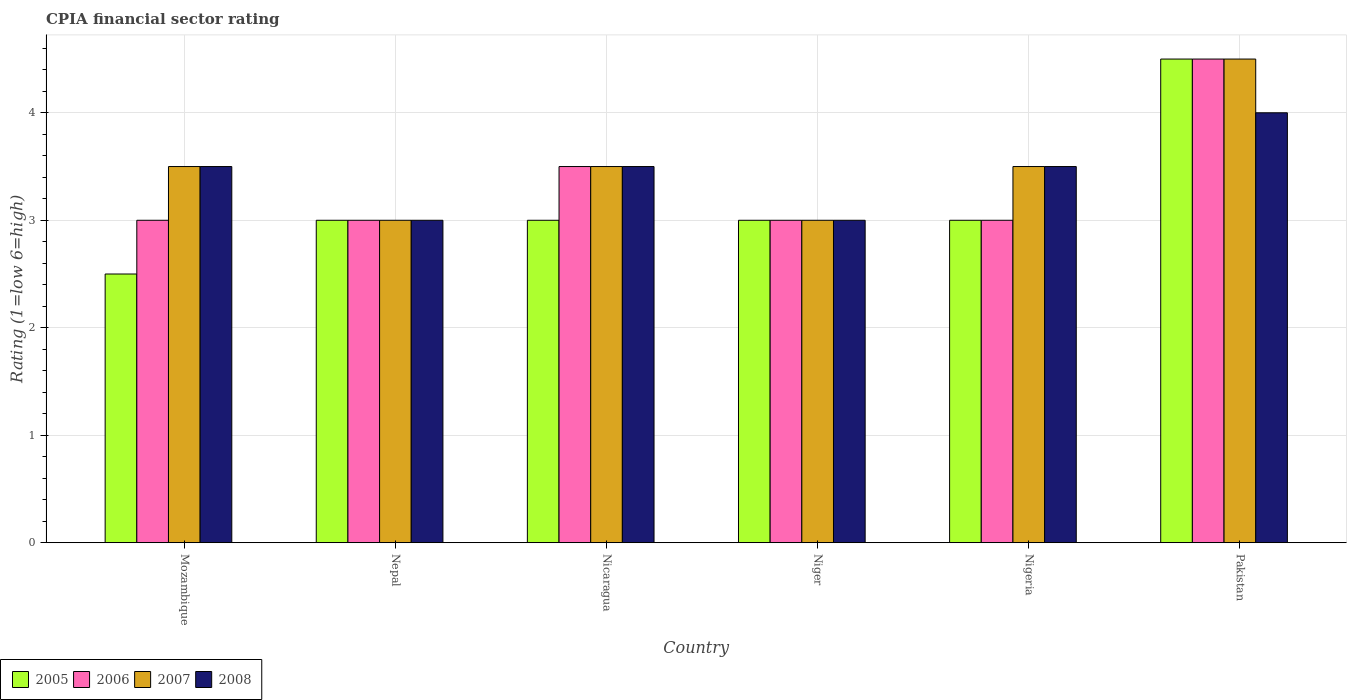How many different coloured bars are there?
Make the answer very short. 4. Are the number of bars on each tick of the X-axis equal?
Make the answer very short. Yes. How many bars are there on the 2nd tick from the left?
Offer a very short reply. 4. How many bars are there on the 2nd tick from the right?
Your answer should be very brief. 4. What is the label of the 2nd group of bars from the left?
Provide a short and direct response. Nepal. Across all countries, what is the minimum CPIA rating in 2006?
Offer a terse response. 3. In which country was the CPIA rating in 2008 maximum?
Make the answer very short. Pakistan. In which country was the CPIA rating in 2008 minimum?
Your response must be concise. Nepal. What is the average CPIA rating in 2005 per country?
Provide a succinct answer. 3.17. In how many countries, is the CPIA rating in 2006 greater than 0.2?
Give a very brief answer. 6. What is the ratio of the CPIA rating in 2006 in Mozambique to that in Niger?
Provide a short and direct response. 1. Is the CPIA rating in 2008 in Nepal less than that in Pakistan?
Your answer should be very brief. Yes. Is the difference between the CPIA rating in 2008 in Nicaragua and Nigeria greater than the difference between the CPIA rating in 2006 in Nicaragua and Nigeria?
Your answer should be compact. No. What is the difference between the highest and the second highest CPIA rating in 2006?
Your answer should be compact. -0.5. Is it the case that in every country, the sum of the CPIA rating in 2007 and CPIA rating in 2006 is greater than the sum of CPIA rating in 2005 and CPIA rating in 2008?
Provide a short and direct response. No. What does the 4th bar from the left in Nigeria represents?
Provide a short and direct response. 2008. How many bars are there?
Give a very brief answer. 24. Are all the bars in the graph horizontal?
Your answer should be very brief. No. How many countries are there in the graph?
Your response must be concise. 6. What is the difference between two consecutive major ticks on the Y-axis?
Make the answer very short. 1. Does the graph contain grids?
Offer a terse response. Yes. Where does the legend appear in the graph?
Offer a very short reply. Bottom left. How many legend labels are there?
Ensure brevity in your answer.  4. How are the legend labels stacked?
Ensure brevity in your answer.  Horizontal. What is the title of the graph?
Ensure brevity in your answer.  CPIA financial sector rating. Does "2011" appear as one of the legend labels in the graph?
Your response must be concise. No. What is the label or title of the Y-axis?
Provide a short and direct response. Rating (1=low 6=high). What is the Rating (1=low 6=high) of 2005 in Mozambique?
Offer a terse response. 2.5. What is the Rating (1=low 6=high) in 2006 in Mozambique?
Ensure brevity in your answer.  3. What is the Rating (1=low 6=high) in 2007 in Mozambique?
Keep it short and to the point. 3.5. What is the Rating (1=low 6=high) of 2005 in Nepal?
Offer a very short reply. 3. What is the Rating (1=low 6=high) in 2007 in Nepal?
Offer a terse response. 3. What is the Rating (1=low 6=high) of 2008 in Nepal?
Make the answer very short. 3. What is the Rating (1=low 6=high) in 2005 in Nicaragua?
Offer a terse response. 3. What is the Rating (1=low 6=high) in 2006 in Nicaragua?
Ensure brevity in your answer.  3.5. What is the Rating (1=low 6=high) in 2007 in Nicaragua?
Ensure brevity in your answer.  3.5. What is the Rating (1=low 6=high) of 2008 in Nicaragua?
Your response must be concise. 3.5. What is the Rating (1=low 6=high) of 2005 in Niger?
Ensure brevity in your answer.  3. What is the Rating (1=low 6=high) of 2007 in Niger?
Ensure brevity in your answer.  3. What is the Rating (1=low 6=high) in 2008 in Nigeria?
Ensure brevity in your answer.  3.5. What is the Rating (1=low 6=high) in 2007 in Pakistan?
Offer a very short reply. 4.5. What is the Rating (1=low 6=high) of 2008 in Pakistan?
Make the answer very short. 4. Across all countries, what is the maximum Rating (1=low 6=high) of 2007?
Your answer should be compact. 4.5. Across all countries, what is the minimum Rating (1=low 6=high) in 2005?
Give a very brief answer. 2.5. Across all countries, what is the minimum Rating (1=low 6=high) of 2008?
Your response must be concise. 3. What is the total Rating (1=low 6=high) of 2005 in the graph?
Ensure brevity in your answer.  19. What is the difference between the Rating (1=low 6=high) of 2006 in Mozambique and that in Nepal?
Make the answer very short. 0. What is the difference between the Rating (1=low 6=high) of 2008 in Mozambique and that in Nepal?
Give a very brief answer. 0.5. What is the difference between the Rating (1=low 6=high) in 2005 in Mozambique and that in Nicaragua?
Ensure brevity in your answer.  -0.5. What is the difference between the Rating (1=low 6=high) in 2006 in Mozambique and that in Nicaragua?
Your answer should be very brief. -0.5. What is the difference between the Rating (1=low 6=high) in 2007 in Mozambique and that in Nicaragua?
Your answer should be very brief. 0. What is the difference between the Rating (1=low 6=high) in 2006 in Mozambique and that in Niger?
Your answer should be compact. 0. What is the difference between the Rating (1=low 6=high) in 2007 in Mozambique and that in Niger?
Provide a short and direct response. 0.5. What is the difference between the Rating (1=low 6=high) in 2008 in Mozambique and that in Niger?
Your response must be concise. 0.5. What is the difference between the Rating (1=low 6=high) of 2005 in Mozambique and that in Nigeria?
Ensure brevity in your answer.  -0.5. What is the difference between the Rating (1=low 6=high) of 2006 in Mozambique and that in Nigeria?
Ensure brevity in your answer.  0. What is the difference between the Rating (1=low 6=high) in 2007 in Mozambique and that in Nigeria?
Your answer should be compact. 0. What is the difference between the Rating (1=low 6=high) in 2008 in Mozambique and that in Nigeria?
Provide a short and direct response. 0. What is the difference between the Rating (1=low 6=high) of 2005 in Nepal and that in Nicaragua?
Keep it short and to the point. 0. What is the difference between the Rating (1=low 6=high) in 2006 in Nepal and that in Nicaragua?
Give a very brief answer. -0.5. What is the difference between the Rating (1=low 6=high) of 2008 in Nepal and that in Niger?
Your response must be concise. 0. What is the difference between the Rating (1=low 6=high) in 2008 in Nepal and that in Nigeria?
Provide a short and direct response. -0.5. What is the difference between the Rating (1=low 6=high) in 2005 in Nepal and that in Pakistan?
Offer a very short reply. -1.5. What is the difference between the Rating (1=low 6=high) in 2007 in Nepal and that in Pakistan?
Keep it short and to the point. -1.5. What is the difference between the Rating (1=low 6=high) of 2008 in Nepal and that in Pakistan?
Your answer should be compact. -1. What is the difference between the Rating (1=low 6=high) of 2006 in Nicaragua and that in Niger?
Provide a short and direct response. 0.5. What is the difference between the Rating (1=low 6=high) in 2007 in Nicaragua and that in Niger?
Offer a terse response. 0.5. What is the difference between the Rating (1=low 6=high) of 2008 in Nicaragua and that in Niger?
Offer a terse response. 0.5. What is the difference between the Rating (1=low 6=high) in 2005 in Nicaragua and that in Nigeria?
Provide a succinct answer. 0. What is the difference between the Rating (1=low 6=high) in 2005 in Nicaragua and that in Pakistan?
Make the answer very short. -1.5. What is the difference between the Rating (1=low 6=high) of 2006 in Nicaragua and that in Pakistan?
Ensure brevity in your answer.  -1. What is the difference between the Rating (1=low 6=high) of 2007 in Nicaragua and that in Pakistan?
Make the answer very short. -1. What is the difference between the Rating (1=low 6=high) in 2005 in Niger and that in Nigeria?
Your response must be concise. 0. What is the difference between the Rating (1=low 6=high) in 2006 in Niger and that in Nigeria?
Give a very brief answer. 0. What is the difference between the Rating (1=low 6=high) in 2006 in Niger and that in Pakistan?
Offer a very short reply. -1.5. What is the difference between the Rating (1=low 6=high) of 2007 in Niger and that in Pakistan?
Offer a very short reply. -1.5. What is the difference between the Rating (1=low 6=high) of 2008 in Niger and that in Pakistan?
Your answer should be very brief. -1. What is the difference between the Rating (1=low 6=high) of 2007 in Nigeria and that in Pakistan?
Make the answer very short. -1. What is the difference between the Rating (1=low 6=high) of 2008 in Nigeria and that in Pakistan?
Give a very brief answer. -0.5. What is the difference between the Rating (1=low 6=high) in 2005 in Mozambique and the Rating (1=low 6=high) in 2006 in Nepal?
Provide a succinct answer. -0.5. What is the difference between the Rating (1=low 6=high) of 2005 in Mozambique and the Rating (1=low 6=high) of 2008 in Nepal?
Your answer should be very brief. -0.5. What is the difference between the Rating (1=low 6=high) in 2006 in Mozambique and the Rating (1=low 6=high) in 2007 in Nepal?
Offer a terse response. 0. What is the difference between the Rating (1=low 6=high) of 2006 in Mozambique and the Rating (1=low 6=high) of 2008 in Nepal?
Offer a very short reply. 0. What is the difference between the Rating (1=low 6=high) in 2005 in Mozambique and the Rating (1=low 6=high) in 2006 in Nicaragua?
Give a very brief answer. -1. What is the difference between the Rating (1=low 6=high) of 2005 in Mozambique and the Rating (1=low 6=high) of 2008 in Nicaragua?
Your answer should be compact. -1. What is the difference between the Rating (1=low 6=high) in 2006 in Mozambique and the Rating (1=low 6=high) in 2008 in Nicaragua?
Provide a short and direct response. -0.5. What is the difference between the Rating (1=low 6=high) of 2007 in Mozambique and the Rating (1=low 6=high) of 2008 in Nicaragua?
Your answer should be compact. 0. What is the difference between the Rating (1=low 6=high) of 2005 in Mozambique and the Rating (1=low 6=high) of 2006 in Niger?
Offer a very short reply. -0.5. What is the difference between the Rating (1=low 6=high) in 2005 in Mozambique and the Rating (1=low 6=high) in 2007 in Niger?
Keep it short and to the point. -0.5. What is the difference between the Rating (1=low 6=high) of 2005 in Mozambique and the Rating (1=low 6=high) of 2008 in Niger?
Your answer should be compact. -0.5. What is the difference between the Rating (1=low 6=high) of 2006 in Mozambique and the Rating (1=low 6=high) of 2007 in Niger?
Provide a succinct answer. 0. What is the difference between the Rating (1=low 6=high) in 2006 in Mozambique and the Rating (1=low 6=high) in 2008 in Niger?
Your answer should be very brief. 0. What is the difference between the Rating (1=low 6=high) in 2005 in Mozambique and the Rating (1=low 6=high) in 2007 in Nigeria?
Give a very brief answer. -1. What is the difference between the Rating (1=low 6=high) in 2005 in Mozambique and the Rating (1=low 6=high) in 2008 in Nigeria?
Give a very brief answer. -1. What is the difference between the Rating (1=low 6=high) in 2006 in Mozambique and the Rating (1=low 6=high) in 2007 in Nigeria?
Your answer should be compact. -0.5. What is the difference between the Rating (1=low 6=high) in 2006 in Mozambique and the Rating (1=low 6=high) in 2008 in Nigeria?
Give a very brief answer. -0.5. What is the difference between the Rating (1=low 6=high) of 2005 in Mozambique and the Rating (1=low 6=high) of 2006 in Pakistan?
Your response must be concise. -2. What is the difference between the Rating (1=low 6=high) in 2005 in Mozambique and the Rating (1=low 6=high) in 2007 in Pakistan?
Keep it short and to the point. -2. What is the difference between the Rating (1=low 6=high) of 2006 in Mozambique and the Rating (1=low 6=high) of 2008 in Pakistan?
Offer a very short reply. -1. What is the difference between the Rating (1=low 6=high) in 2005 in Nepal and the Rating (1=low 6=high) in 2007 in Nicaragua?
Ensure brevity in your answer.  -0.5. What is the difference between the Rating (1=low 6=high) of 2006 in Nepal and the Rating (1=low 6=high) of 2007 in Nicaragua?
Give a very brief answer. -0.5. What is the difference between the Rating (1=low 6=high) in 2006 in Nepal and the Rating (1=low 6=high) in 2008 in Nicaragua?
Your response must be concise. -0.5. What is the difference between the Rating (1=low 6=high) in 2007 in Nepal and the Rating (1=low 6=high) in 2008 in Nicaragua?
Your response must be concise. -0.5. What is the difference between the Rating (1=low 6=high) in 2005 in Nepal and the Rating (1=low 6=high) in 2006 in Niger?
Provide a short and direct response. 0. What is the difference between the Rating (1=low 6=high) of 2005 in Nepal and the Rating (1=low 6=high) of 2007 in Niger?
Your answer should be very brief. 0. What is the difference between the Rating (1=low 6=high) in 2005 in Nepal and the Rating (1=low 6=high) in 2008 in Niger?
Ensure brevity in your answer.  0. What is the difference between the Rating (1=low 6=high) in 2006 in Nepal and the Rating (1=low 6=high) in 2007 in Niger?
Provide a succinct answer. 0. What is the difference between the Rating (1=low 6=high) in 2006 in Nepal and the Rating (1=low 6=high) in 2008 in Niger?
Provide a short and direct response. 0. What is the difference between the Rating (1=low 6=high) of 2005 in Nepal and the Rating (1=low 6=high) of 2007 in Nigeria?
Offer a terse response. -0.5. What is the difference between the Rating (1=low 6=high) in 2007 in Nepal and the Rating (1=low 6=high) in 2008 in Nigeria?
Make the answer very short. -0.5. What is the difference between the Rating (1=low 6=high) of 2005 in Nepal and the Rating (1=low 6=high) of 2006 in Pakistan?
Keep it short and to the point. -1.5. What is the difference between the Rating (1=low 6=high) of 2007 in Nepal and the Rating (1=low 6=high) of 2008 in Pakistan?
Provide a short and direct response. -1. What is the difference between the Rating (1=low 6=high) of 2005 in Nicaragua and the Rating (1=low 6=high) of 2006 in Niger?
Ensure brevity in your answer.  0. What is the difference between the Rating (1=low 6=high) of 2005 in Nicaragua and the Rating (1=low 6=high) of 2008 in Niger?
Your response must be concise. 0. What is the difference between the Rating (1=low 6=high) in 2007 in Nicaragua and the Rating (1=low 6=high) in 2008 in Niger?
Provide a short and direct response. 0.5. What is the difference between the Rating (1=low 6=high) in 2005 in Nicaragua and the Rating (1=low 6=high) in 2006 in Nigeria?
Your answer should be very brief. 0. What is the difference between the Rating (1=low 6=high) of 2005 in Nicaragua and the Rating (1=low 6=high) of 2007 in Nigeria?
Offer a very short reply. -0.5. What is the difference between the Rating (1=low 6=high) of 2005 in Nicaragua and the Rating (1=low 6=high) of 2008 in Nigeria?
Make the answer very short. -0.5. What is the difference between the Rating (1=low 6=high) in 2005 in Nicaragua and the Rating (1=low 6=high) in 2006 in Pakistan?
Ensure brevity in your answer.  -1.5. What is the difference between the Rating (1=low 6=high) in 2006 in Nicaragua and the Rating (1=low 6=high) in 2007 in Pakistan?
Give a very brief answer. -1. What is the difference between the Rating (1=low 6=high) in 2007 in Nicaragua and the Rating (1=low 6=high) in 2008 in Pakistan?
Your answer should be compact. -0.5. What is the difference between the Rating (1=low 6=high) of 2005 in Niger and the Rating (1=low 6=high) of 2006 in Nigeria?
Your answer should be compact. 0. What is the difference between the Rating (1=low 6=high) in 2005 in Niger and the Rating (1=low 6=high) in 2007 in Nigeria?
Your answer should be compact. -0.5. What is the difference between the Rating (1=low 6=high) in 2005 in Niger and the Rating (1=low 6=high) in 2008 in Nigeria?
Provide a succinct answer. -0.5. What is the difference between the Rating (1=low 6=high) in 2006 in Niger and the Rating (1=low 6=high) in 2008 in Nigeria?
Your response must be concise. -0.5. What is the difference between the Rating (1=low 6=high) of 2005 in Niger and the Rating (1=low 6=high) of 2006 in Pakistan?
Your answer should be compact. -1.5. What is the difference between the Rating (1=low 6=high) in 2005 in Niger and the Rating (1=low 6=high) in 2007 in Pakistan?
Your answer should be compact. -1.5. What is the difference between the Rating (1=low 6=high) of 2005 in Niger and the Rating (1=low 6=high) of 2008 in Pakistan?
Make the answer very short. -1. What is the difference between the Rating (1=low 6=high) in 2006 in Niger and the Rating (1=low 6=high) in 2007 in Pakistan?
Your response must be concise. -1.5. What is the difference between the Rating (1=low 6=high) of 2006 in Niger and the Rating (1=low 6=high) of 2008 in Pakistan?
Provide a succinct answer. -1. What is the difference between the Rating (1=low 6=high) of 2007 in Niger and the Rating (1=low 6=high) of 2008 in Pakistan?
Ensure brevity in your answer.  -1. What is the difference between the Rating (1=low 6=high) in 2005 in Nigeria and the Rating (1=low 6=high) in 2006 in Pakistan?
Give a very brief answer. -1.5. What is the difference between the Rating (1=low 6=high) of 2006 in Nigeria and the Rating (1=low 6=high) of 2007 in Pakistan?
Offer a terse response. -1.5. What is the difference between the Rating (1=low 6=high) of 2006 in Nigeria and the Rating (1=low 6=high) of 2008 in Pakistan?
Make the answer very short. -1. What is the difference between the Rating (1=low 6=high) of 2007 in Nigeria and the Rating (1=low 6=high) of 2008 in Pakistan?
Ensure brevity in your answer.  -0.5. What is the average Rating (1=low 6=high) in 2005 per country?
Ensure brevity in your answer.  3.17. What is the average Rating (1=low 6=high) of 2006 per country?
Provide a short and direct response. 3.33. What is the average Rating (1=low 6=high) of 2008 per country?
Keep it short and to the point. 3.42. What is the difference between the Rating (1=low 6=high) of 2005 and Rating (1=low 6=high) of 2007 in Mozambique?
Make the answer very short. -1. What is the difference between the Rating (1=low 6=high) in 2006 and Rating (1=low 6=high) in 2007 in Mozambique?
Your response must be concise. -0.5. What is the difference between the Rating (1=low 6=high) of 2006 and Rating (1=low 6=high) of 2008 in Mozambique?
Your answer should be compact. -0.5. What is the difference between the Rating (1=low 6=high) of 2007 and Rating (1=low 6=high) of 2008 in Mozambique?
Offer a terse response. 0. What is the difference between the Rating (1=low 6=high) in 2005 and Rating (1=low 6=high) in 2006 in Nepal?
Ensure brevity in your answer.  0. What is the difference between the Rating (1=low 6=high) of 2005 and Rating (1=low 6=high) of 2008 in Nepal?
Your answer should be very brief. 0. What is the difference between the Rating (1=low 6=high) of 2006 and Rating (1=low 6=high) of 2008 in Nepal?
Offer a very short reply. 0. What is the difference between the Rating (1=low 6=high) in 2005 and Rating (1=low 6=high) in 2006 in Nicaragua?
Your response must be concise. -0.5. What is the difference between the Rating (1=low 6=high) in 2005 and Rating (1=low 6=high) in 2007 in Nicaragua?
Your response must be concise. -0.5. What is the difference between the Rating (1=low 6=high) in 2007 and Rating (1=low 6=high) in 2008 in Nicaragua?
Make the answer very short. 0. What is the difference between the Rating (1=low 6=high) in 2005 and Rating (1=low 6=high) in 2006 in Niger?
Keep it short and to the point. 0. What is the difference between the Rating (1=low 6=high) in 2006 and Rating (1=low 6=high) in 2007 in Niger?
Offer a very short reply. 0. What is the difference between the Rating (1=low 6=high) in 2005 and Rating (1=low 6=high) in 2006 in Nigeria?
Keep it short and to the point. 0. What is the difference between the Rating (1=low 6=high) of 2005 and Rating (1=low 6=high) of 2007 in Nigeria?
Your answer should be compact. -0.5. What is the difference between the Rating (1=low 6=high) in 2005 and Rating (1=low 6=high) in 2006 in Pakistan?
Ensure brevity in your answer.  0. What is the difference between the Rating (1=low 6=high) in 2005 and Rating (1=low 6=high) in 2008 in Pakistan?
Keep it short and to the point. 0.5. What is the difference between the Rating (1=low 6=high) in 2006 and Rating (1=low 6=high) in 2007 in Pakistan?
Ensure brevity in your answer.  0. What is the difference between the Rating (1=low 6=high) in 2006 and Rating (1=low 6=high) in 2008 in Pakistan?
Your response must be concise. 0.5. What is the difference between the Rating (1=low 6=high) of 2007 and Rating (1=low 6=high) of 2008 in Pakistan?
Offer a very short reply. 0.5. What is the ratio of the Rating (1=low 6=high) in 2005 in Mozambique to that in Nepal?
Ensure brevity in your answer.  0.83. What is the ratio of the Rating (1=low 6=high) of 2007 in Mozambique to that in Nepal?
Ensure brevity in your answer.  1.17. What is the ratio of the Rating (1=low 6=high) of 2008 in Mozambique to that in Nepal?
Keep it short and to the point. 1.17. What is the ratio of the Rating (1=low 6=high) of 2005 in Mozambique to that in Nicaragua?
Keep it short and to the point. 0.83. What is the ratio of the Rating (1=low 6=high) of 2006 in Mozambique to that in Nicaragua?
Ensure brevity in your answer.  0.86. What is the ratio of the Rating (1=low 6=high) of 2008 in Mozambique to that in Nicaragua?
Ensure brevity in your answer.  1. What is the ratio of the Rating (1=low 6=high) of 2005 in Mozambique to that in Niger?
Your answer should be compact. 0.83. What is the ratio of the Rating (1=low 6=high) in 2006 in Mozambique to that in Niger?
Offer a very short reply. 1. What is the ratio of the Rating (1=low 6=high) of 2007 in Mozambique to that in Niger?
Ensure brevity in your answer.  1.17. What is the ratio of the Rating (1=low 6=high) of 2008 in Mozambique to that in Niger?
Your answer should be compact. 1.17. What is the ratio of the Rating (1=low 6=high) of 2008 in Mozambique to that in Nigeria?
Make the answer very short. 1. What is the ratio of the Rating (1=low 6=high) of 2005 in Mozambique to that in Pakistan?
Provide a succinct answer. 0.56. What is the ratio of the Rating (1=low 6=high) of 2008 in Mozambique to that in Pakistan?
Your response must be concise. 0.88. What is the ratio of the Rating (1=low 6=high) in 2006 in Nepal to that in Nicaragua?
Your answer should be very brief. 0.86. What is the ratio of the Rating (1=low 6=high) of 2007 in Nepal to that in Nicaragua?
Keep it short and to the point. 0.86. What is the ratio of the Rating (1=low 6=high) in 2008 in Nepal to that in Nicaragua?
Offer a very short reply. 0.86. What is the ratio of the Rating (1=low 6=high) in 2005 in Nepal to that in Niger?
Make the answer very short. 1. What is the ratio of the Rating (1=low 6=high) in 2006 in Nepal to that in Niger?
Provide a succinct answer. 1. What is the ratio of the Rating (1=low 6=high) of 2007 in Nepal to that in Nigeria?
Ensure brevity in your answer.  0.86. What is the ratio of the Rating (1=low 6=high) in 2008 in Nepal to that in Nigeria?
Your response must be concise. 0.86. What is the ratio of the Rating (1=low 6=high) of 2007 in Nepal to that in Pakistan?
Your answer should be compact. 0.67. What is the ratio of the Rating (1=low 6=high) in 2005 in Nicaragua to that in Niger?
Give a very brief answer. 1. What is the ratio of the Rating (1=low 6=high) of 2006 in Nicaragua to that in Niger?
Your response must be concise. 1.17. What is the ratio of the Rating (1=low 6=high) of 2006 in Nicaragua to that in Nigeria?
Make the answer very short. 1.17. What is the ratio of the Rating (1=low 6=high) of 2007 in Nicaragua to that in Nigeria?
Your answer should be very brief. 1. What is the ratio of the Rating (1=low 6=high) in 2006 in Nicaragua to that in Pakistan?
Provide a short and direct response. 0.78. What is the ratio of the Rating (1=low 6=high) in 2007 in Nicaragua to that in Pakistan?
Your answer should be very brief. 0.78. What is the ratio of the Rating (1=low 6=high) in 2008 in Nicaragua to that in Pakistan?
Ensure brevity in your answer.  0.88. What is the ratio of the Rating (1=low 6=high) of 2008 in Niger to that in Nigeria?
Ensure brevity in your answer.  0.86. What is the ratio of the Rating (1=low 6=high) of 2008 in Niger to that in Pakistan?
Ensure brevity in your answer.  0.75. What is the difference between the highest and the second highest Rating (1=low 6=high) in 2006?
Provide a succinct answer. 1. What is the difference between the highest and the second highest Rating (1=low 6=high) of 2007?
Keep it short and to the point. 1. What is the difference between the highest and the second highest Rating (1=low 6=high) in 2008?
Provide a short and direct response. 0.5. What is the difference between the highest and the lowest Rating (1=low 6=high) in 2006?
Offer a very short reply. 1.5. What is the difference between the highest and the lowest Rating (1=low 6=high) of 2008?
Provide a short and direct response. 1. 